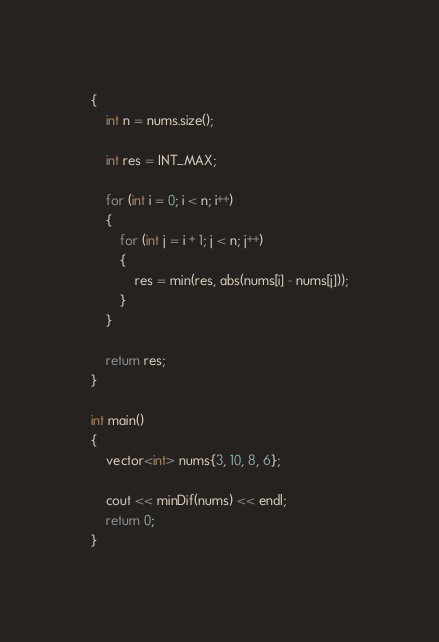<code> <loc_0><loc_0><loc_500><loc_500><_C++_>{
	int n = nums.size();

	int res = INT_MAX;

	for (int i = 0; i < n; i++)
	{
		for (int j = i + 1; j < n; j++)
		{
			res = min(res, abs(nums[i] - nums[j]));
		}
	}

	return res;
}

int main()
{
	vector<int> nums{3, 10, 8, 6};

	cout << minDif(nums) << endl;
	return 0;
}</code> 